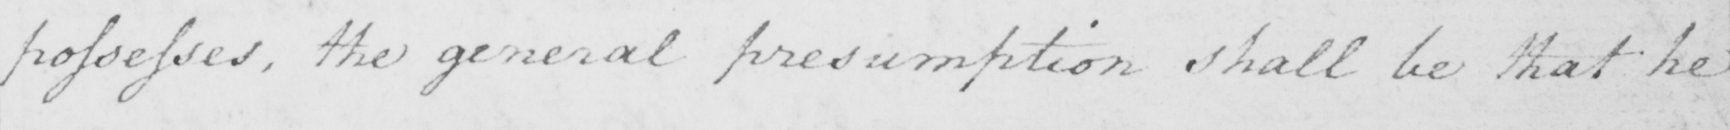Please provide the text content of this handwritten line. possesses , the general presumption shall be that he 